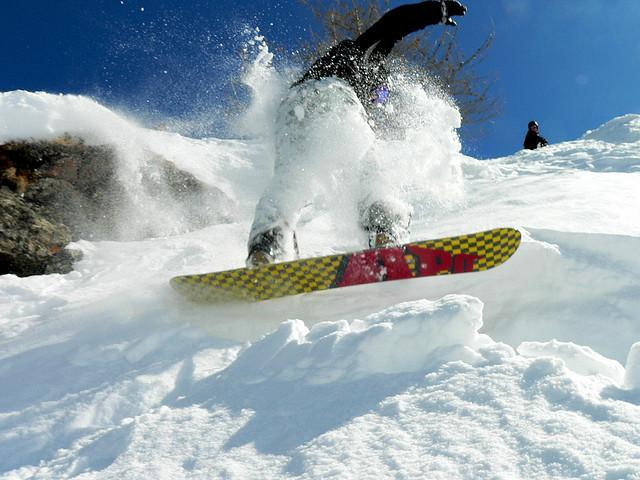How deep is the snow?
Short answer required. 2 feet. Would cowabunga be a proper exclamation for this scene?
Be succinct. Yes. Is this a person or snow?
Concise answer only. Both. 